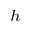Convert formula to latex. <formula><loc_0><loc_0><loc_500><loc_500>^ { h }</formula> 